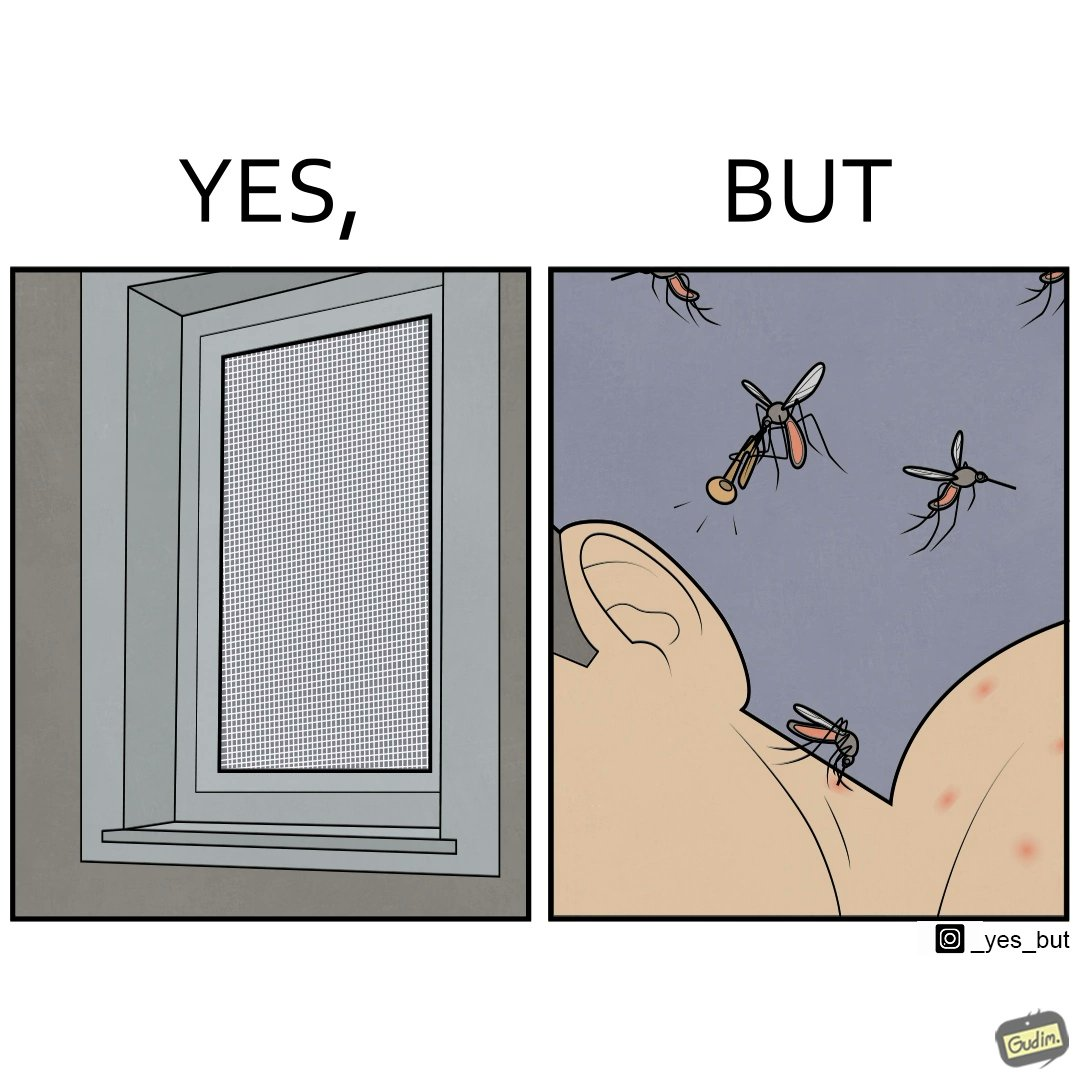Is this image satirical or non-satirical? Yes, this image is satirical. 